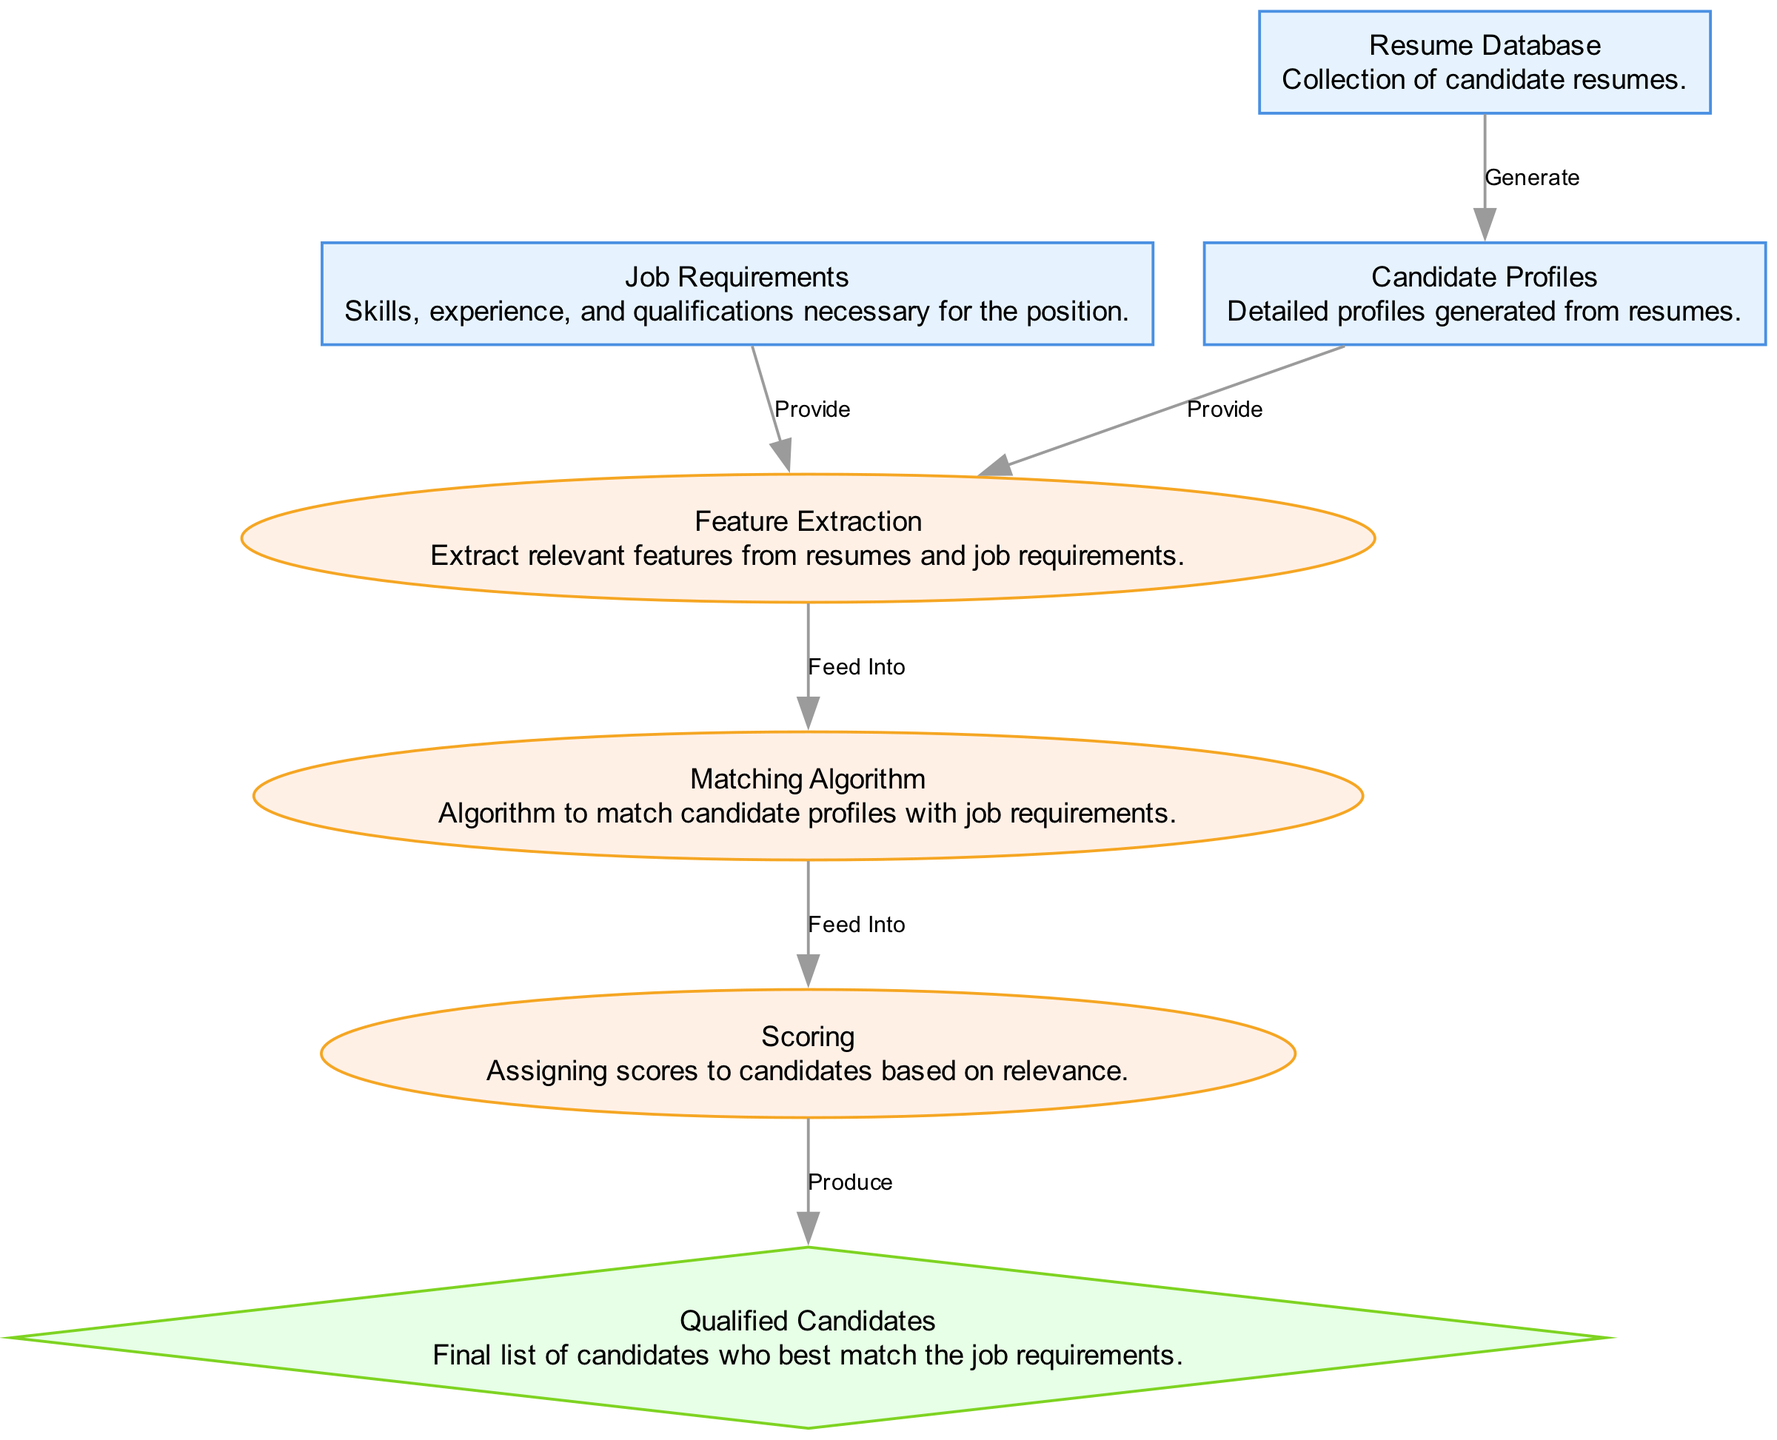What is the first node in the diagram? The first node in the diagram is "Job Requirements," which is identified as the starting point that outlines the necessary skills, experience, and qualifications for the position.
Answer: Job Requirements How many nodes are present in the diagram? The diagram contains a total of seven nodes, covering job requirements, resume database, candidate profiles, feature extraction, matching algorithm, scoring, and qualified candidates.
Answer: Seven What edge connects "Job Requirements" to the next step? The edge that connects "Job Requirements" to the next step is labeled "Provide," indicating that the job requirements provide the necessary input for the feature extraction process.
Answer: Provide Which node represents the final output? The final output in the diagram is represented by the node "Qualified Candidates," which is the end result of the matching and scoring process that identifies the best candidates for the job.
Answer: Qualified Candidates What does the "Matching Algorithm" do in the process? The "Matching Algorithm" feeds into the next step, which is scoring. This indicates that it takes the extracted features from candidate profiles and job requirements to evaluate and find matches.
Answer: Feed Into How many edges are there in total in the diagram? There are six edges in total, each representing a connection between different nodes that describe how data flows through the candidate matching algorithm.
Answer: Six What is the direct relationship between "Resume Database" and "Candidate Profiles"? The direct relationship is labeled "Generate," indicating that the resume database is used to generate detailed candidate profiles.
Answer: Generate Which process follows "Feature Extraction"? The process that follows "Feature Extraction" is the "Matching Algorithm," which utilizes the extracted features to identify corresponding candidates for the job requirements.
Answer: Matching Algorithm What type of node is "Scoring"? "Scoring" is categorized as a process type node, which involves assessing the candidates based on their relevance to the job requirements after matching.
Answer: Process 